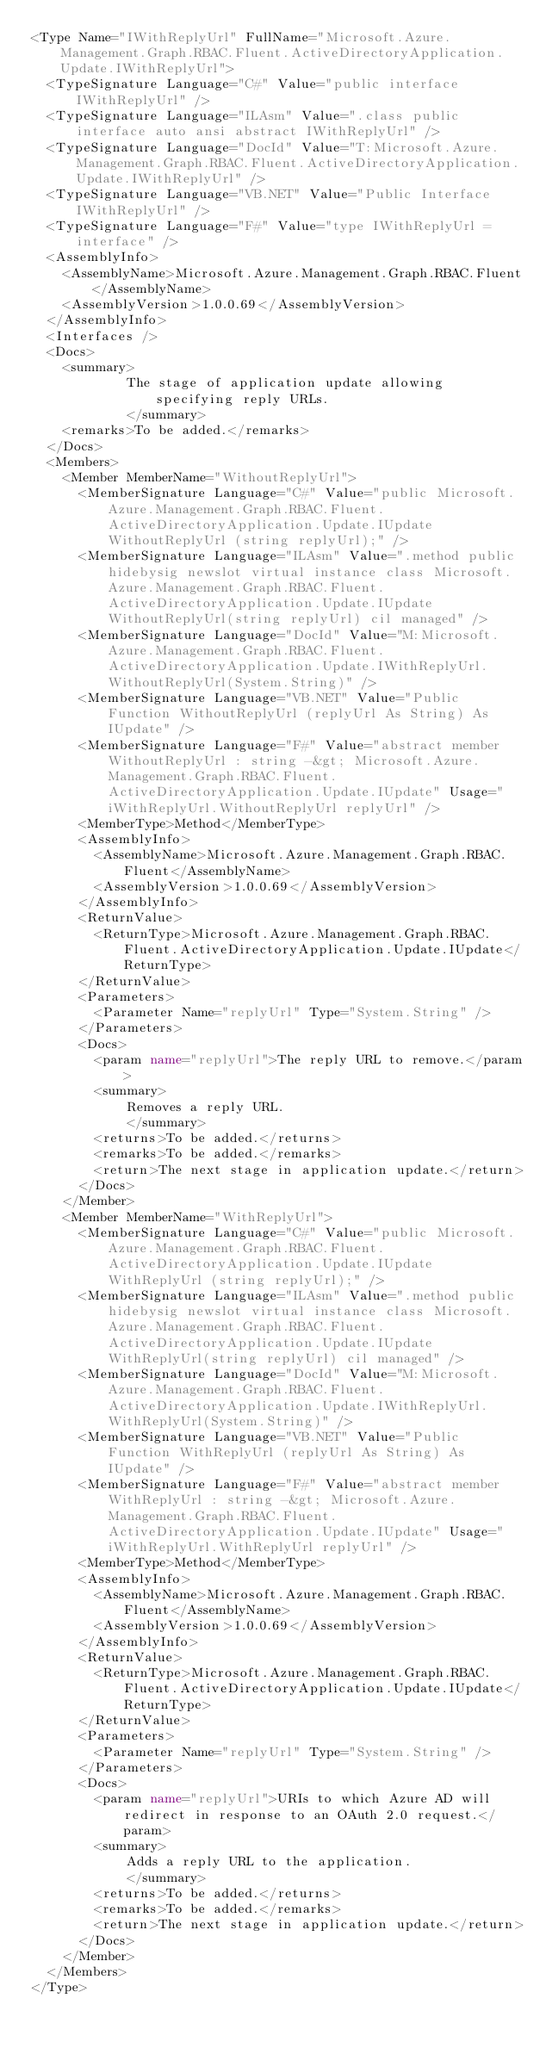<code> <loc_0><loc_0><loc_500><loc_500><_XML_><Type Name="IWithReplyUrl" FullName="Microsoft.Azure.Management.Graph.RBAC.Fluent.ActiveDirectoryApplication.Update.IWithReplyUrl">
  <TypeSignature Language="C#" Value="public interface IWithReplyUrl" />
  <TypeSignature Language="ILAsm" Value=".class public interface auto ansi abstract IWithReplyUrl" />
  <TypeSignature Language="DocId" Value="T:Microsoft.Azure.Management.Graph.RBAC.Fluent.ActiveDirectoryApplication.Update.IWithReplyUrl" />
  <TypeSignature Language="VB.NET" Value="Public Interface IWithReplyUrl" />
  <TypeSignature Language="F#" Value="type IWithReplyUrl = interface" />
  <AssemblyInfo>
    <AssemblyName>Microsoft.Azure.Management.Graph.RBAC.Fluent</AssemblyName>
    <AssemblyVersion>1.0.0.69</AssemblyVersion>
  </AssemblyInfo>
  <Interfaces />
  <Docs>
    <summary>
            The stage of application update allowing specifying reply URLs.
            </summary>
    <remarks>To be added.</remarks>
  </Docs>
  <Members>
    <Member MemberName="WithoutReplyUrl">
      <MemberSignature Language="C#" Value="public Microsoft.Azure.Management.Graph.RBAC.Fluent.ActiveDirectoryApplication.Update.IUpdate WithoutReplyUrl (string replyUrl);" />
      <MemberSignature Language="ILAsm" Value=".method public hidebysig newslot virtual instance class Microsoft.Azure.Management.Graph.RBAC.Fluent.ActiveDirectoryApplication.Update.IUpdate WithoutReplyUrl(string replyUrl) cil managed" />
      <MemberSignature Language="DocId" Value="M:Microsoft.Azure.Management.Graph.RBAC.Fluent.ActiveDirectoryApplication.Update.IWithReplyUrl.WithoutReplyUrl(System.String)" />
      <MemberSignature Language="VB.NET" Value="Public Function WithoutReplyUrl (replyUrl As String) As IUpdate" />
      <MemberSignature Language="F#" Value="abstract member WithoutReplyUrl : string -&gt; Microsoft.Azure.Management.Graph.RBAC.Fluent.ActiveDirectoryApplication.Update.IUpdate" Usage="iWithReplyUrl.WithoutReplyUrl replyUrl" />
      <MemberType>Method</MemberType>
      <AssemblyInfo>
        <AssemblyName>Microsoft.Azure.Management.Graph.RBAC.Fluent</AssemblyName>
        <AssemblyVersion>1.0.0.69</AssemblyVersion>
      </AssemblyInfo>
      <ReturnValue>
        <ReturnType>Microsoft.Azure.Management.Graph.RBAC.Fluent.ActiveDirectoryApplication.Update.IUpdate</ReturnType>
      </ReturnValue>
      <Parameters>
        <Parameter Name="replyUrl" Type="System.String" />
      </Parameters>
      <Docs>
        <param name="replyUrl">The reply URL to remove.</param>
        <summary>
            Removes a reply URL.
            </summary>
        <returns>To be added.</returns>
        <remarks>To be added.</remarks>
        <return>The next stage in application update.</return>
      </Docs>
    </Member>
    <Member MemberName="WithReplyUrl">
      <MemberSignature Language="C#" Value="public Microsoft.Azure.Management.Graph.RBAC.Fluent.ActiveDirectoryApplication.Update.IUpdate WithReplyUrl (string replyUrl);" />
      <MemberSignature Language="ILAsm" Value=".method public hidebysig newslot virtual instance class Microsoft.Azure.Management.Graph.RBAC.Fluent.ActiveDirectoryApplication.Update.IUpdate WithReplyUrl(string replyUrl) cil managed" />
      <MemberSignature Language="DocId" Value="M:Microsoft.Azure.Management.Graph.RBAC.Fluent.ActiveDirectoryApplication.Update.IWithReplyUrl.WithReplyUrl(System.String)" />
      <MemberSignature Language="VB.NET" Value="Public Function WithReplyUrl (replyUrl As String) As IUpdate" />
      <MemberSignature Language="F#" Value="abstract member WithReplyUrl : string -&gt; Microsoft.Azure.Management.Graph.RBAC.Fluent.ActiveDirectoryApplication.Update.IUpdate" Usage="iWithReplyUrl.WithReplyUrl replyUrl" />
      <MemberType>Method</MemberType>
      <AssemblyInfo>
        <AssemblyName>Microsoft.Azure.Management.Graph.RBAC.Fluent</AssemblyName>
        <AssemblyVersion>1.0.0.69</AssemblyVersion>
      </AssemblyInfo>
      <ReturnValue>
        <ReturnType>Microsoft.Azure.Management.Graph.RBAC.Fluent.ActiveDirectoryApplication.Update.IUpdate</ReturnType>
      </ReturnValue>
      <Parameters>
        <Parameter Name="replyUrl" Type="System.String" />
      </Parameters>
      <Docs>
        <param name="replyUrl">URIs to which Azure AD will redirect in response to an OAuth 2.0 request.</param>
        <summary>
            Adds a reply URL to the application.
            </summary>
        <returns>To be added.</returns>
        <remarks>To be added.</remarks>
        <return>The next stage in application update.</return>
      </Docs>
    </Member>
  </Members>
</Type>
</code> 